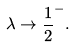<formula> <loc_0><loc_0><loc_500><loc_500>\lambda \rightarrow \frac { 1 } { 2 } ^ { - } .</formula> 